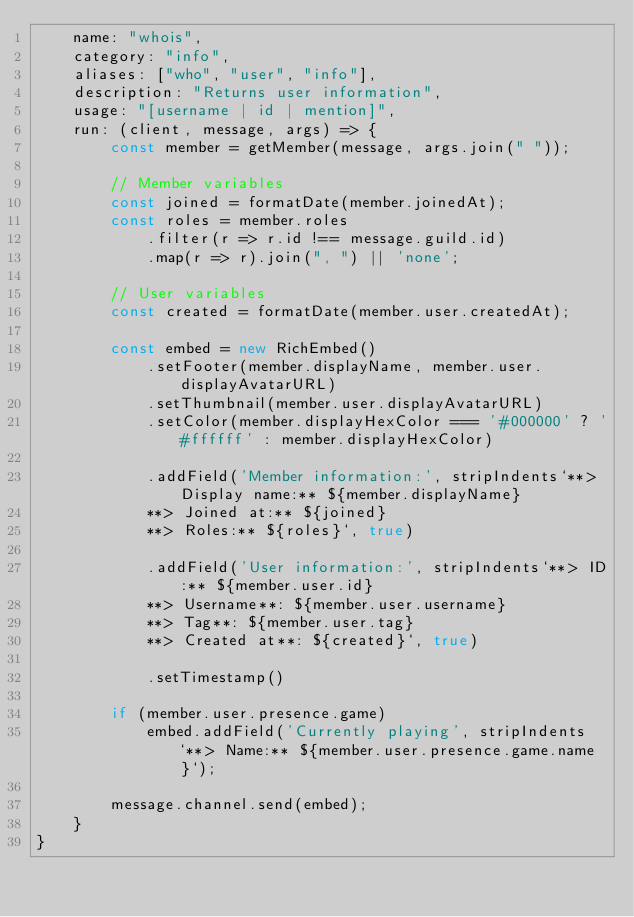Convert code to text. <code><loc_0><loc_0><loc_500><loc_500><_JavaScript_>    name: "whois",
    category: "info",
    aliases: ["who", "user", "info"],
    description: "Returns user information",
    usage: "[username | id | mention]",
    run: (client, message, args) => {
        const member = getMember(message, args.join(" "));

        // Member variables
        const joined = formatDate(member.joinedAt);
        const roles = member.roles
            .filter(r => r.id !== message.guild.id)
            .map(r => r).join(", ") || 'none';

        // User variables
        const created = formatDate(member.user.createdAt);

        const embed = new RichEmbed()
            .setFooter(member.displayName, member.user.displayAvatarURL)
            .setThumbnail(member.user.displayAvatarURL)
            .setColor(member.displayHexColor === '#000000' ? '#ffffff' : member.displayHexColor)

            .addField('Member information:', stripIndents`**> Display name:** ${member.displayName}
            **> Joined at:** ${joined}
            **> Roles:** ${roles}`, true)

            .addField('User information:', stripIndents`**> ID:** ${member.user.id}
            **> Username**: ${member.user.username}
            **> Tag**: ${member.user.tag}
            **> Created at**: ${created}`, true)
            
            .setTimestamp()

        if (member.user.presence.game) 
            embed.addField('Currently playing', stripIndents`**> Name:** ${member.user.presence.game.name}`);

        message.channel.send(embed);
    }
}</code> 